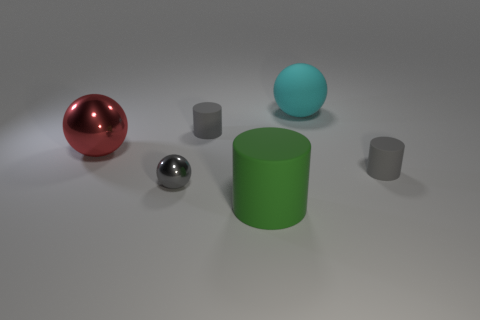Are there fewer large red metallic objects that are in front of the large red object than gray matte cylinders?
Keep it short and to the point. Yes. What number of gray metal things have the same size as the green cylinder?
Your answer should be very brief. 0. There is a tiny matte object in front of the red metallic object; is it the same color as the thing that is in front of the tiny gray shiny ball?
Give a very brief answer. No. What number of small gray balls are to the right of the tiny gray shiny thing?
Offer a terse response. 0. Are there any gray rubber objects of the same shape as the large cyan rubber thing?
Your answer should be very brief. No. There is a shiny ball that is the same size as the green matte cylinder; what is its color?
Make the answer very short. Red. Is the number of small objects that are behind the red metallic thing less than the number of matte things in front of the large matte cylinder?
Your answer should be very brief. No. Do the gray rubber cylinder that is to the left of the cyan matte thing and the red object have the same size?
Your answer should be compact. No. What shape is the matte object to the right of the large cyan ball?
Offer a very short reply. Cylinder. Is the number of tiny cyan shiny cylinders greater than the number of green matte cylinders?
Offer a terse response. No. 